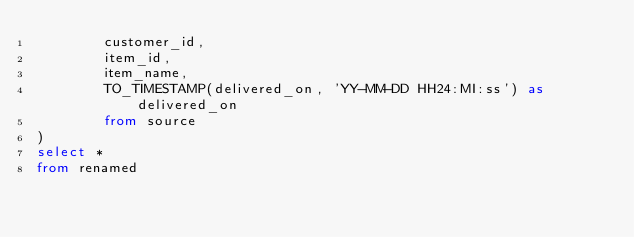Convert code to text. <code><loc_0><loc_0><loc_500><loc_500><_SQL_>        customer_id,
        item_id,
        item_name,
        TO_TIMESTAMP(delivered_on, 'YY-MM-DD HH24:MI:ss') as delivered_on
        from source
)
select *
from renamed</code> 